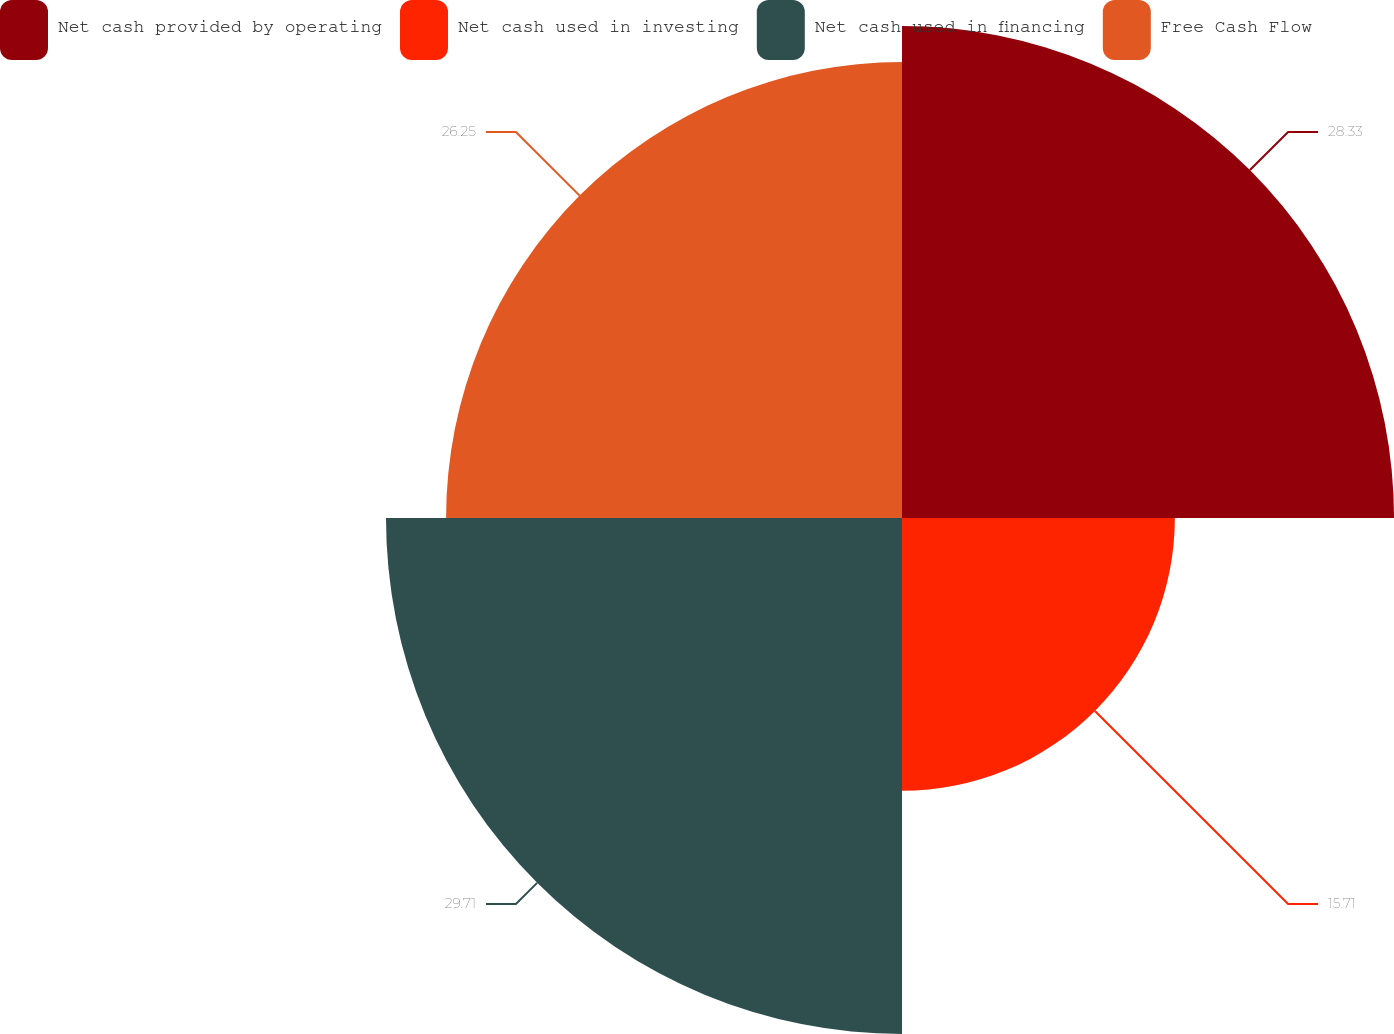<chart> <loc_0><loc_0><loc_500><loc_500><pie_chart><fcel>Net cash provided by operating<fcel>Net cash used in investing<fcel>Net cash used in financing<fcel>Free Cash Flow<nl><fcel>28.33%<fcel>15.71%<fcel>29.71%<fcel>26.25%<nl></chart> 